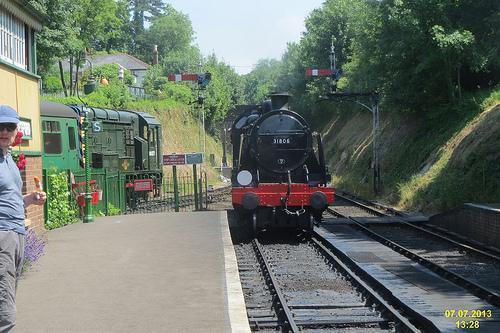How many people are in the picture?
Give a very brief answer. 1. 